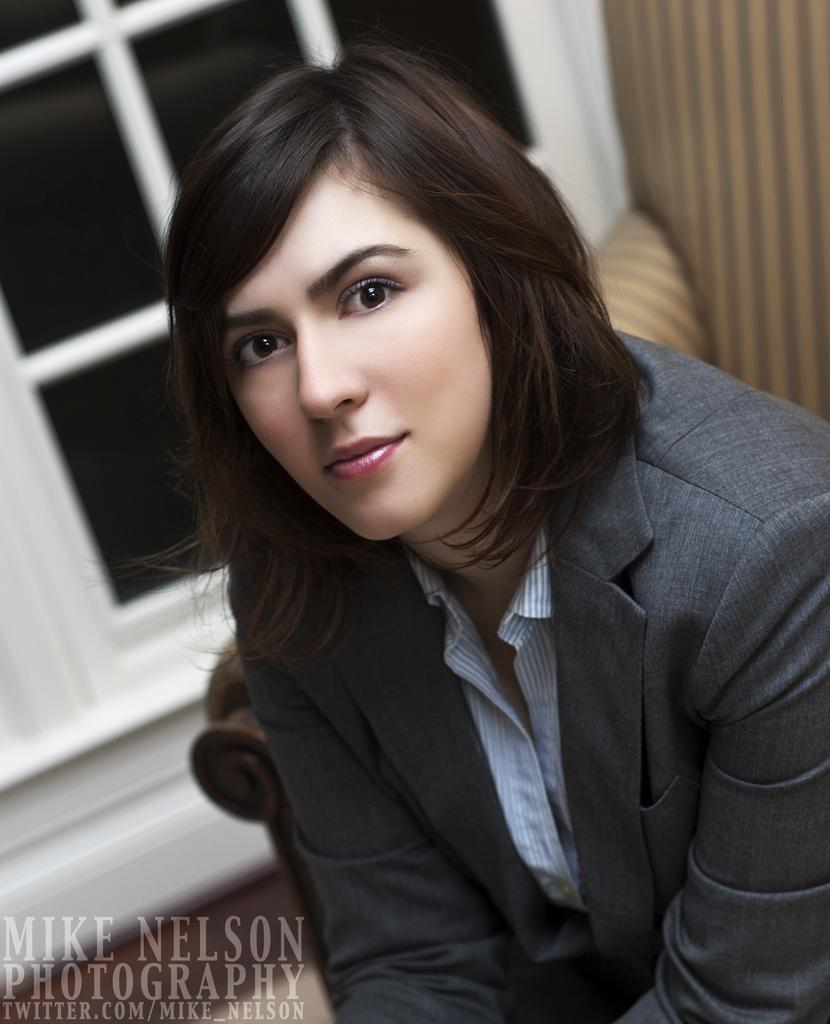Who is present in the image? There is a woman in the image. What can be seen in the background of the image? There is a window in the background of the image. Is there any additional information about the image itself? Yes, there is a watermark in the left bottom corner of the image. What type of kettle is being used to smash the plough in the image? There is no kettle, smashing, or plough present in the image. 